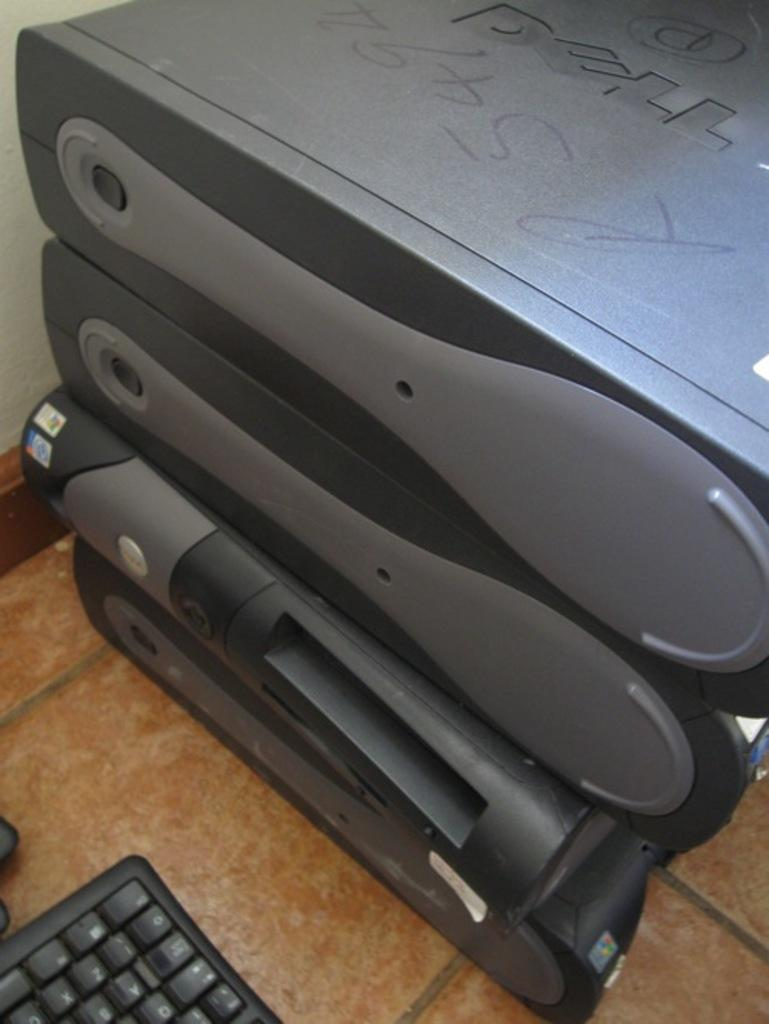Provide a one-sentence caption for the provided image. Several computer towers sit on top of each other, with the top one being branded from DELL. 